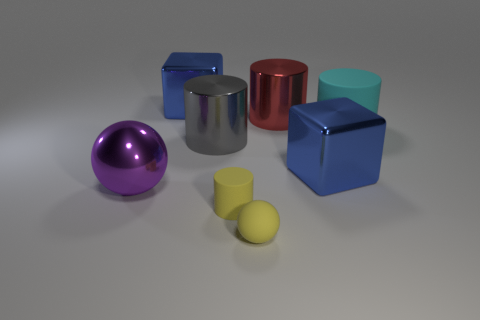Subtract all red metallic cylinders. How many cylinders are left? 3 Subtract all spheres. How many objects are left? 6 Subtract all yellow cylinders. How many cylinders are left? 3 Add 2 large blue blocks. How many objects exist? 10 Subtract 1 cylinders. How many cylinders are left? 3 Subtract all cyan cylinders. Subtract all yellow cubes. How many cylinders are left? 3 Subtract all gray cylinders. How many purple spheres are left? 1 Subtract all large gray rubber cylinders. Subtract all cyan matte cylinders. How many objects are left? 7 Add 1 large blue things. How many large blue things are left? 3 Add 5 brown blocks. How many brown blocks exist? 5 